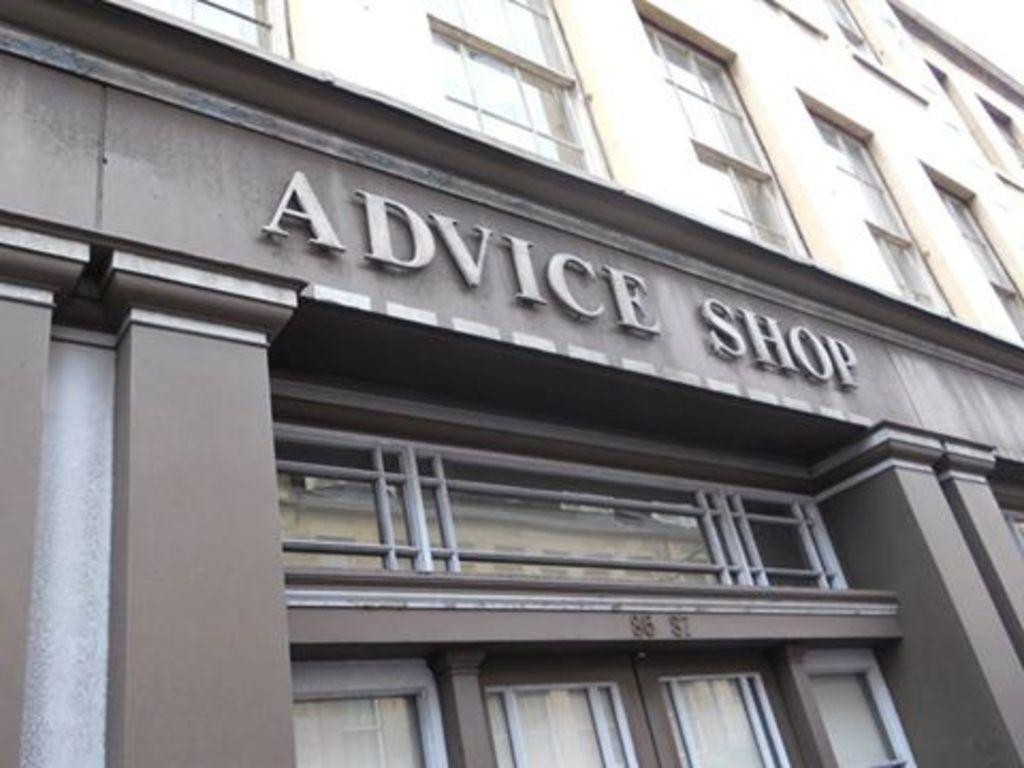What is the main subject in the foreground of the image? There is a building in the foreground of the image. What features can be observed on the building? The building has windows, and the text "ADVICE SHOP" is present on it. How many cherries are hanging from the vest in the image? There is no vest or cherries present in the image. 